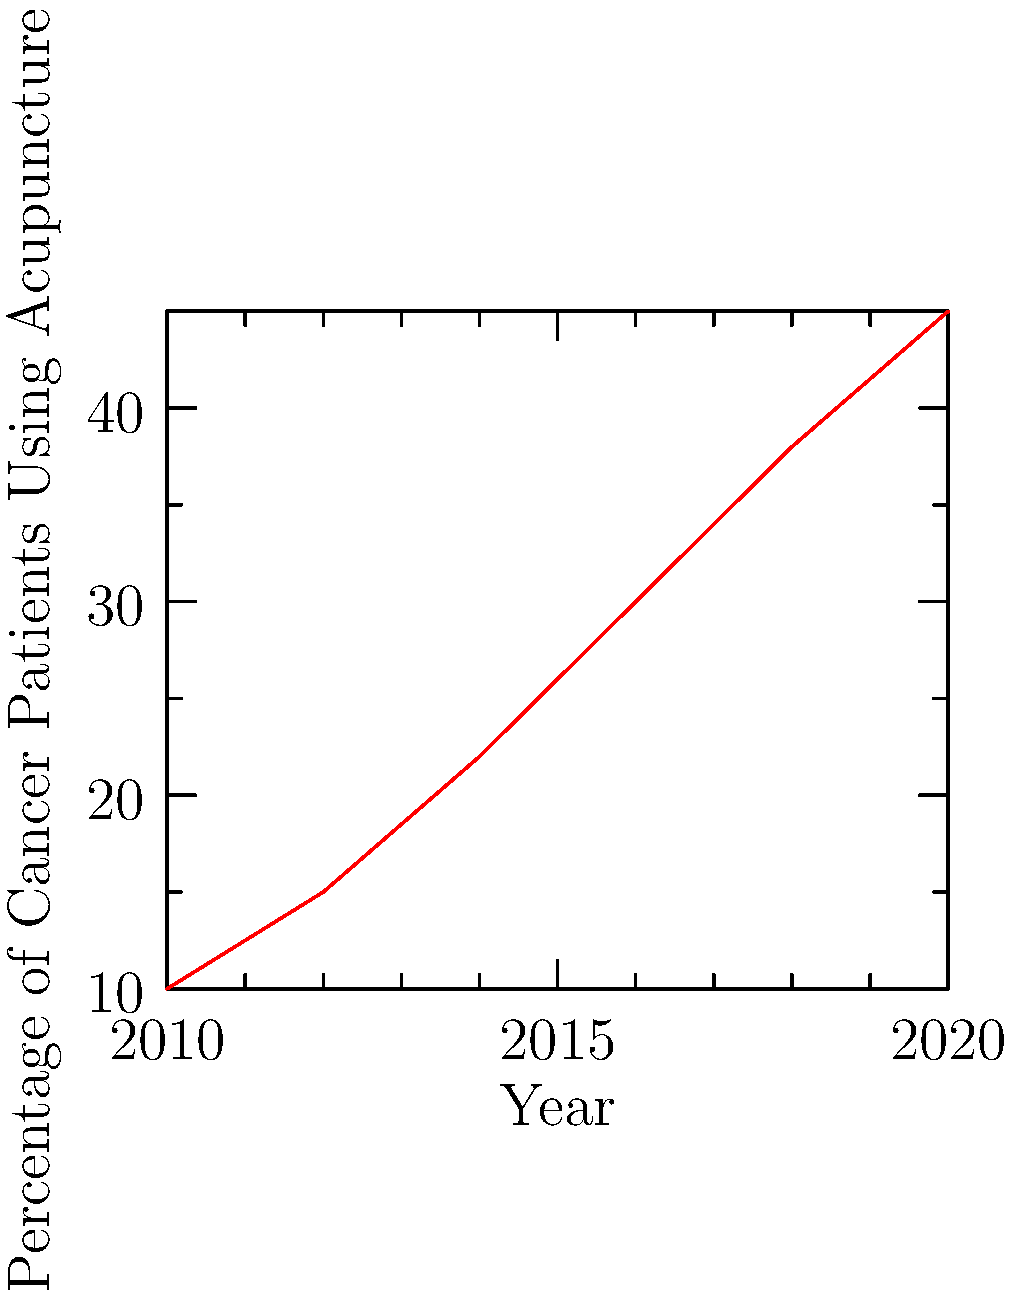Based on the trend shown in the line graph, what is the estimated percentage of cancer patients using acupuncture in 2022 if the trend continues? To estimate the percentage of cancer patients using acupuncture in 2022, we need to:

1. Observe the trend: The graph shows a steady increase in acupuncture usage from 2010 to 2020.

2. Calculate the rate of increase:
   - In 2010: 10%
   - In 2020: 45%
   - Total increase over 10 years: 45% - 10% = 35%
   - Average increase per year: 35% / 10 years = 3.5% per year

3. Extend the trend:
   - 2020 percentage: 45%
   - 2022 is 2 years after 2020
   - Estimated increase: 3.5% × 2 years = 7%

4. Calculate the 2022 estimate:
   45% (2020 value) + 7% (estimated increase) = 52%

Therefore, if the trend continues, the estimated percentage of cancer patients using acupuncture in 2022 would be approximately 52%.
Answer: 52% 